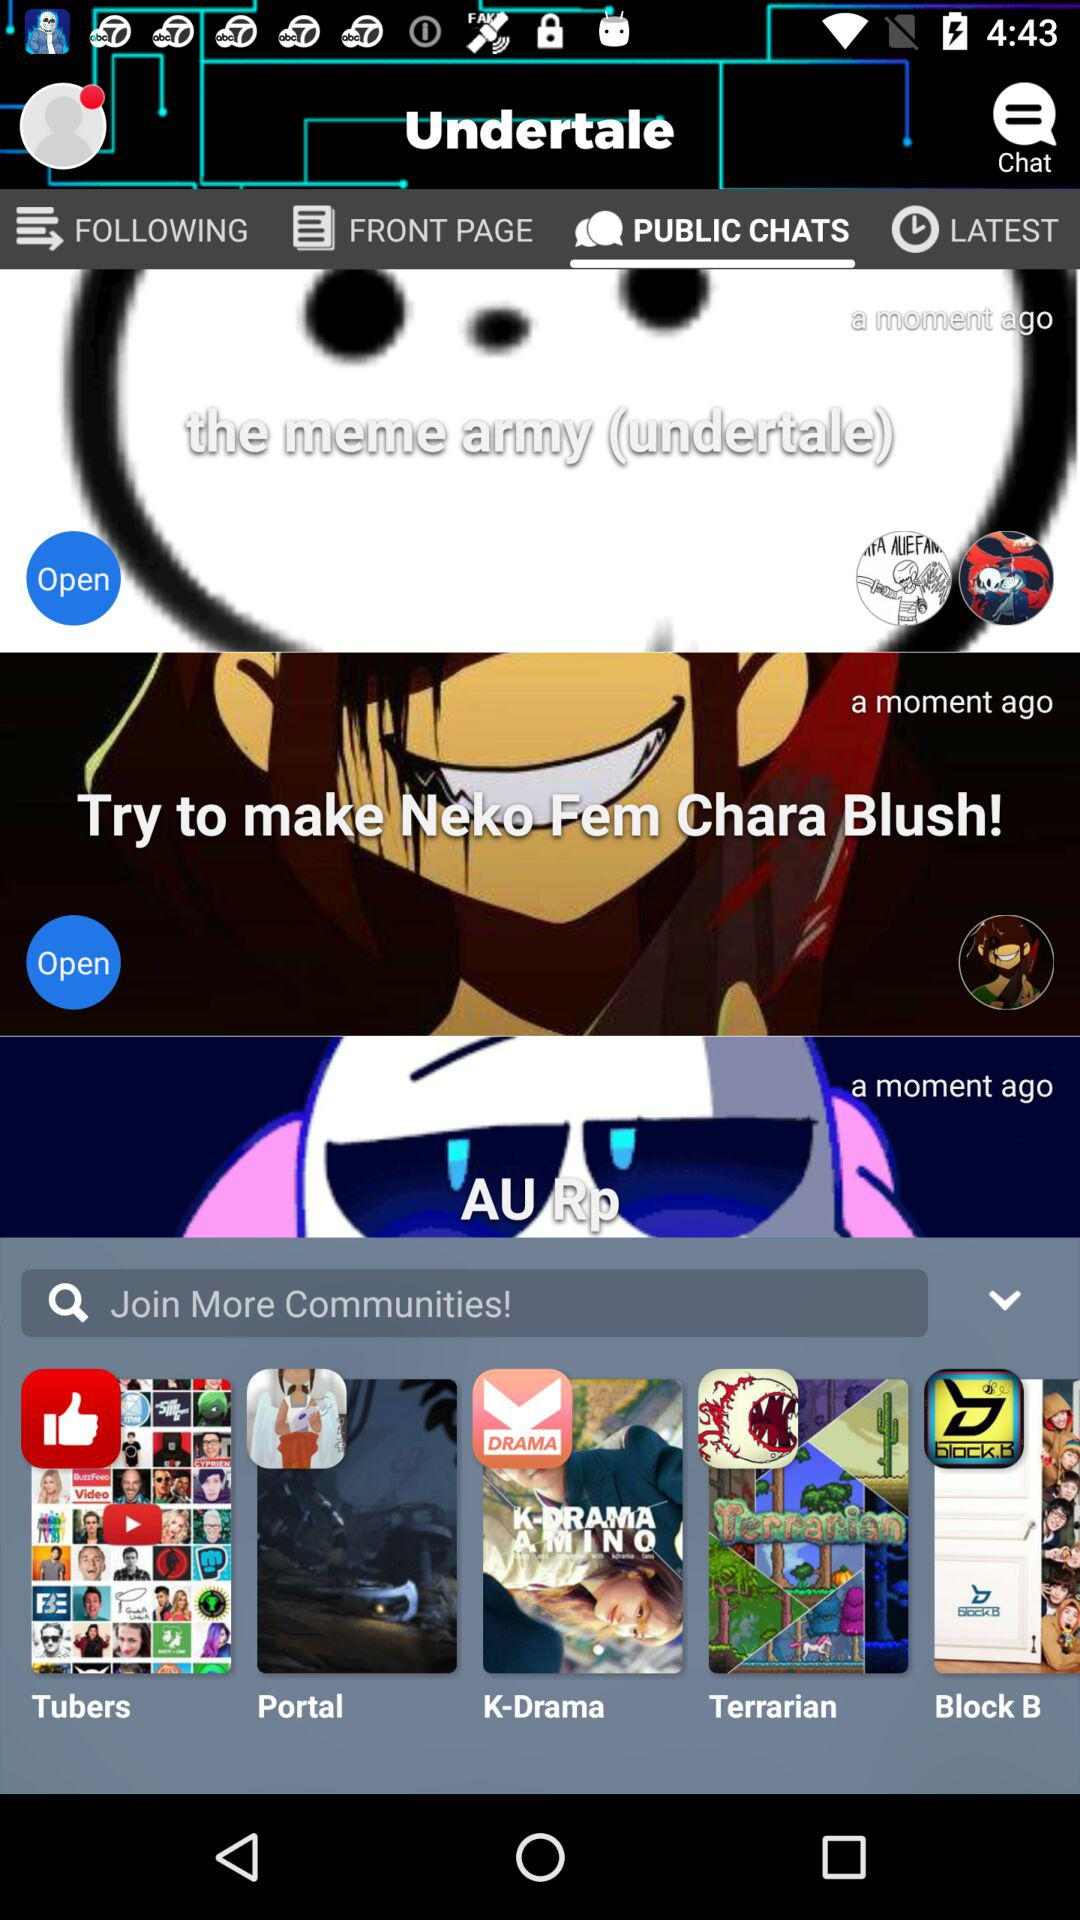Which option is selected? The selected option is "PUBLIC CHATS". 